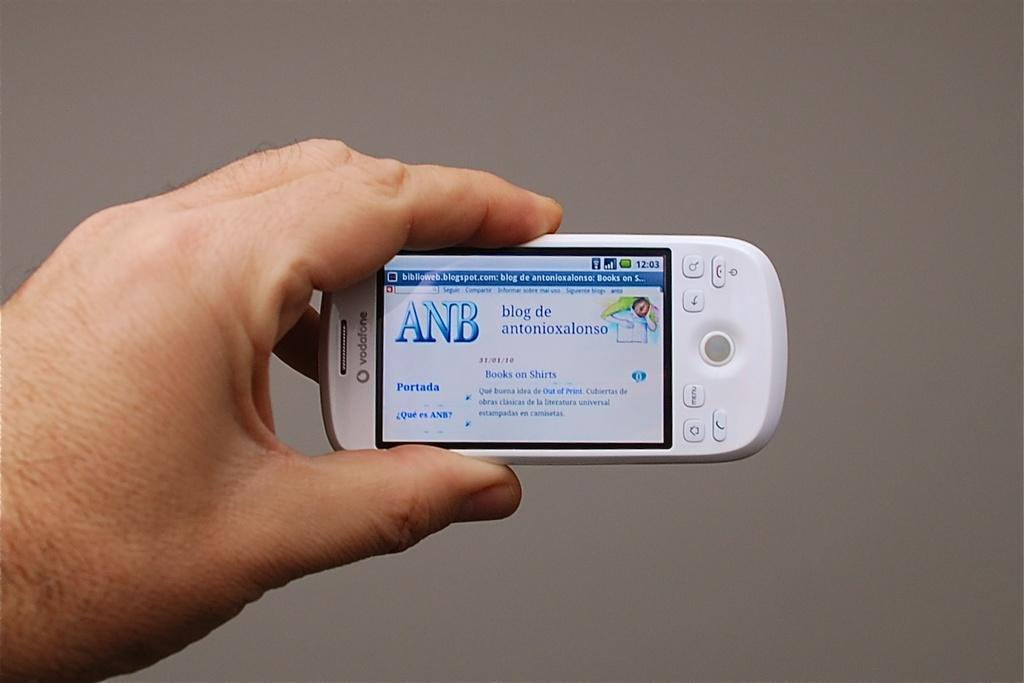<image>
Describe the image concisely. A hand holding a white cell phone that reads ANB. 